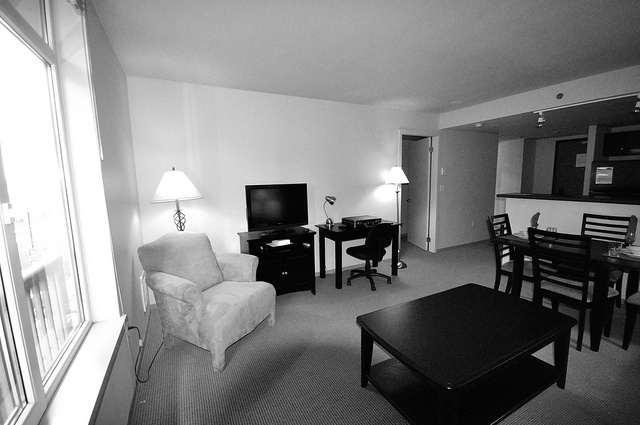Describe the objects in this image and their specific colors. I can see chair in gray, darkgray, lightgray, and black tones, chair in gray, black, darkgray, and lightgray tones, dining table in gray, black, darkgray, and lightgray tones, tv in black, gray, and darkgray tones, and chair in gray, black, darkgray, and lightgray tones in this image. 